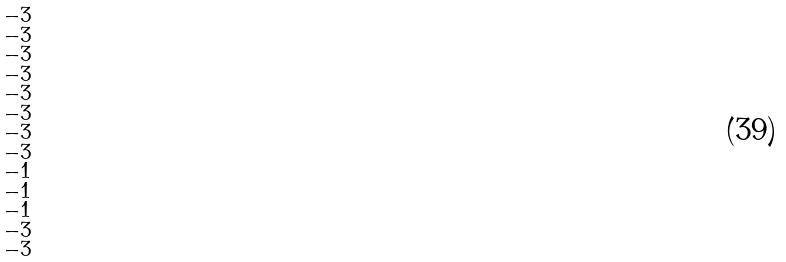<formula> <loc_0><loc_0><loc_500><loc_500>\begin{smallmatrix} - 3 \\ - 3 \\ - 3 \\ - 3 \\ - 3 \\ - 3 \\ - 3 \\ - 3 \\ - 1 \\ - 1 \\ - 1 \\ - 3 \\ - 3 \\ \end{smallmatrix}</formula> 